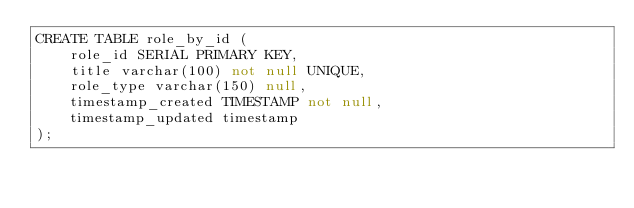<code> <loc_0><loc_0><loc_500><loc_500><_SQL_>CREATE TABLE role_by_id (
    role_id SERIAL PRIMARY KEY,
    title varchar(100) not null UNIQUE,
    role_type varchar(150) null,
    timestamp_created TIMESTAMP not null,
    timestamp_updated timestamp
);</code> 